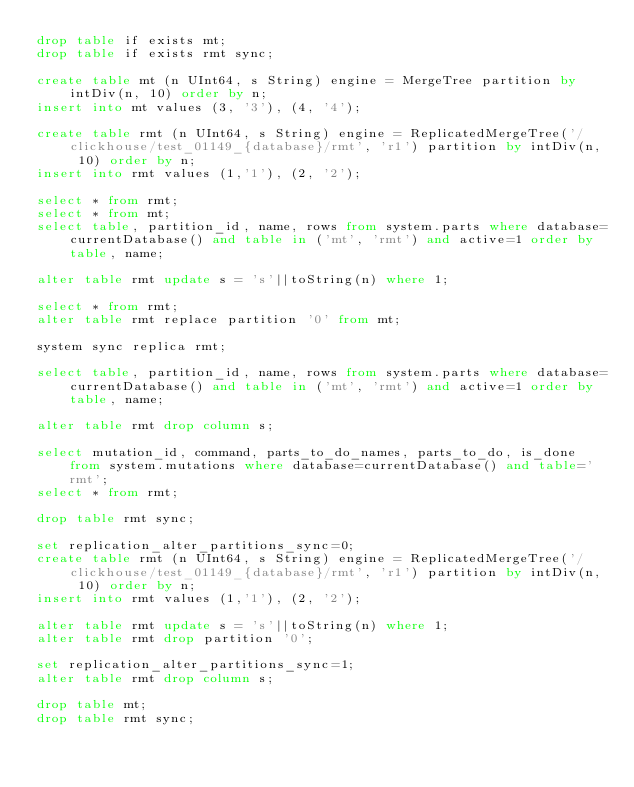<code> <loc_0><loc_0><loc_500><loc_500><_SQL_>drop table if exists mt;
drop table if exists rmt sync;

create table mt (n UInt64, s String) engine = MergeTree partition by intDiv(n, 10) order by n;
insert into mt values (3, '3'), (4, '4');

create table rmt (n UInt64, s String) engine = ReplicatedMergeTree('/clickhouse/test_01149_{database}/rmt', 'r1') partition by intDiv(n, 10) order by n;
insert into rmt values (1,'1'), (2, '2');

select * from rmt;
select * from mt;
select table, partition_id, name, rows from system.parts where database=currentDatabase() and table in ('mt', 'rmt') and active=1 order by table, name;

alter table rmt update s = 's'||toString(n) where 1;

select * from rmt;
alter table rmt replace partition '0' from mt;

system sync replica rmt;

select table, partition_id, name, rows from system.parts where database=currentDatabase() and table in ('mt', 'rmt') and active=1 order by table, name;

alter table rmt drop column s;

select mutation_id, command, parts_to_do_names, parts_to_do, is_done from system.mutations where database=currentDatabase() and table='rmt';
select * from rmt;

drop table rmt sync;

set replication_alter_partitions_sync=0;
create table rmt (n UInt64, s String) engine = ReplicatedMergeTree('/clickhouse/test_01149_{database}/rmt', 'r1') partition by intDiv(n, 10) order by n;
insert into rmt values (1,'1'), (2, '2');

alter table rmt update s = 's'||toString(n) where 1;
alter table rmt drop partition '0';

set replication_alter_partitions_sync=1;
alter table rmt drop column s;

drop table mt;
drop table rmt sync;
</code> 